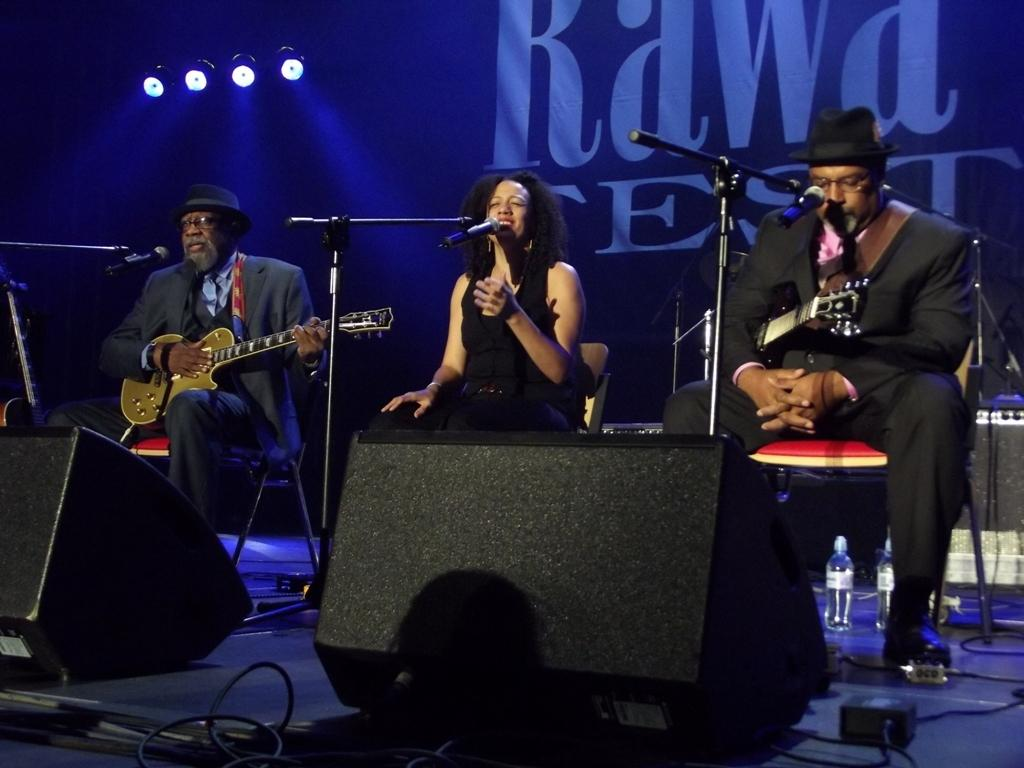What is the man in the image doing? The man is sitting on a chair and playing a guitar. What is the woman in the image doing? The woman is singing into a microphone. How many people are sitting on chairs in the image? There are two people sitting on chairs in the image. What can be seen in the background of the image? There are lights visible in the background of the image. What color is the sock worn by the man playing the guitar in the image? There is no mention of a sock in the image, as the man is wearing shoes while playing the guitar. 